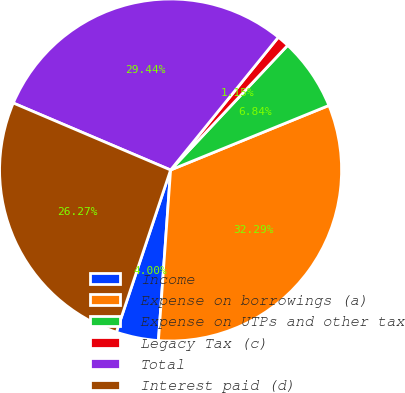<chart> <loc_0><loc_0><loc_500><loc_500><pie_chart><fcel>Income<fcel>Expense on borrowings (a)<fcel>Expense on UTPs and other tax<fcel>Legacy Tax (c)<fcel>Total<fcel>Interest paid (d)<nl><fcel>4.0%<fcel>32.29%<fcel>6.84%<fcel>1.15%<fcel>29.44%<fcel>26.27%<nl></chart> 